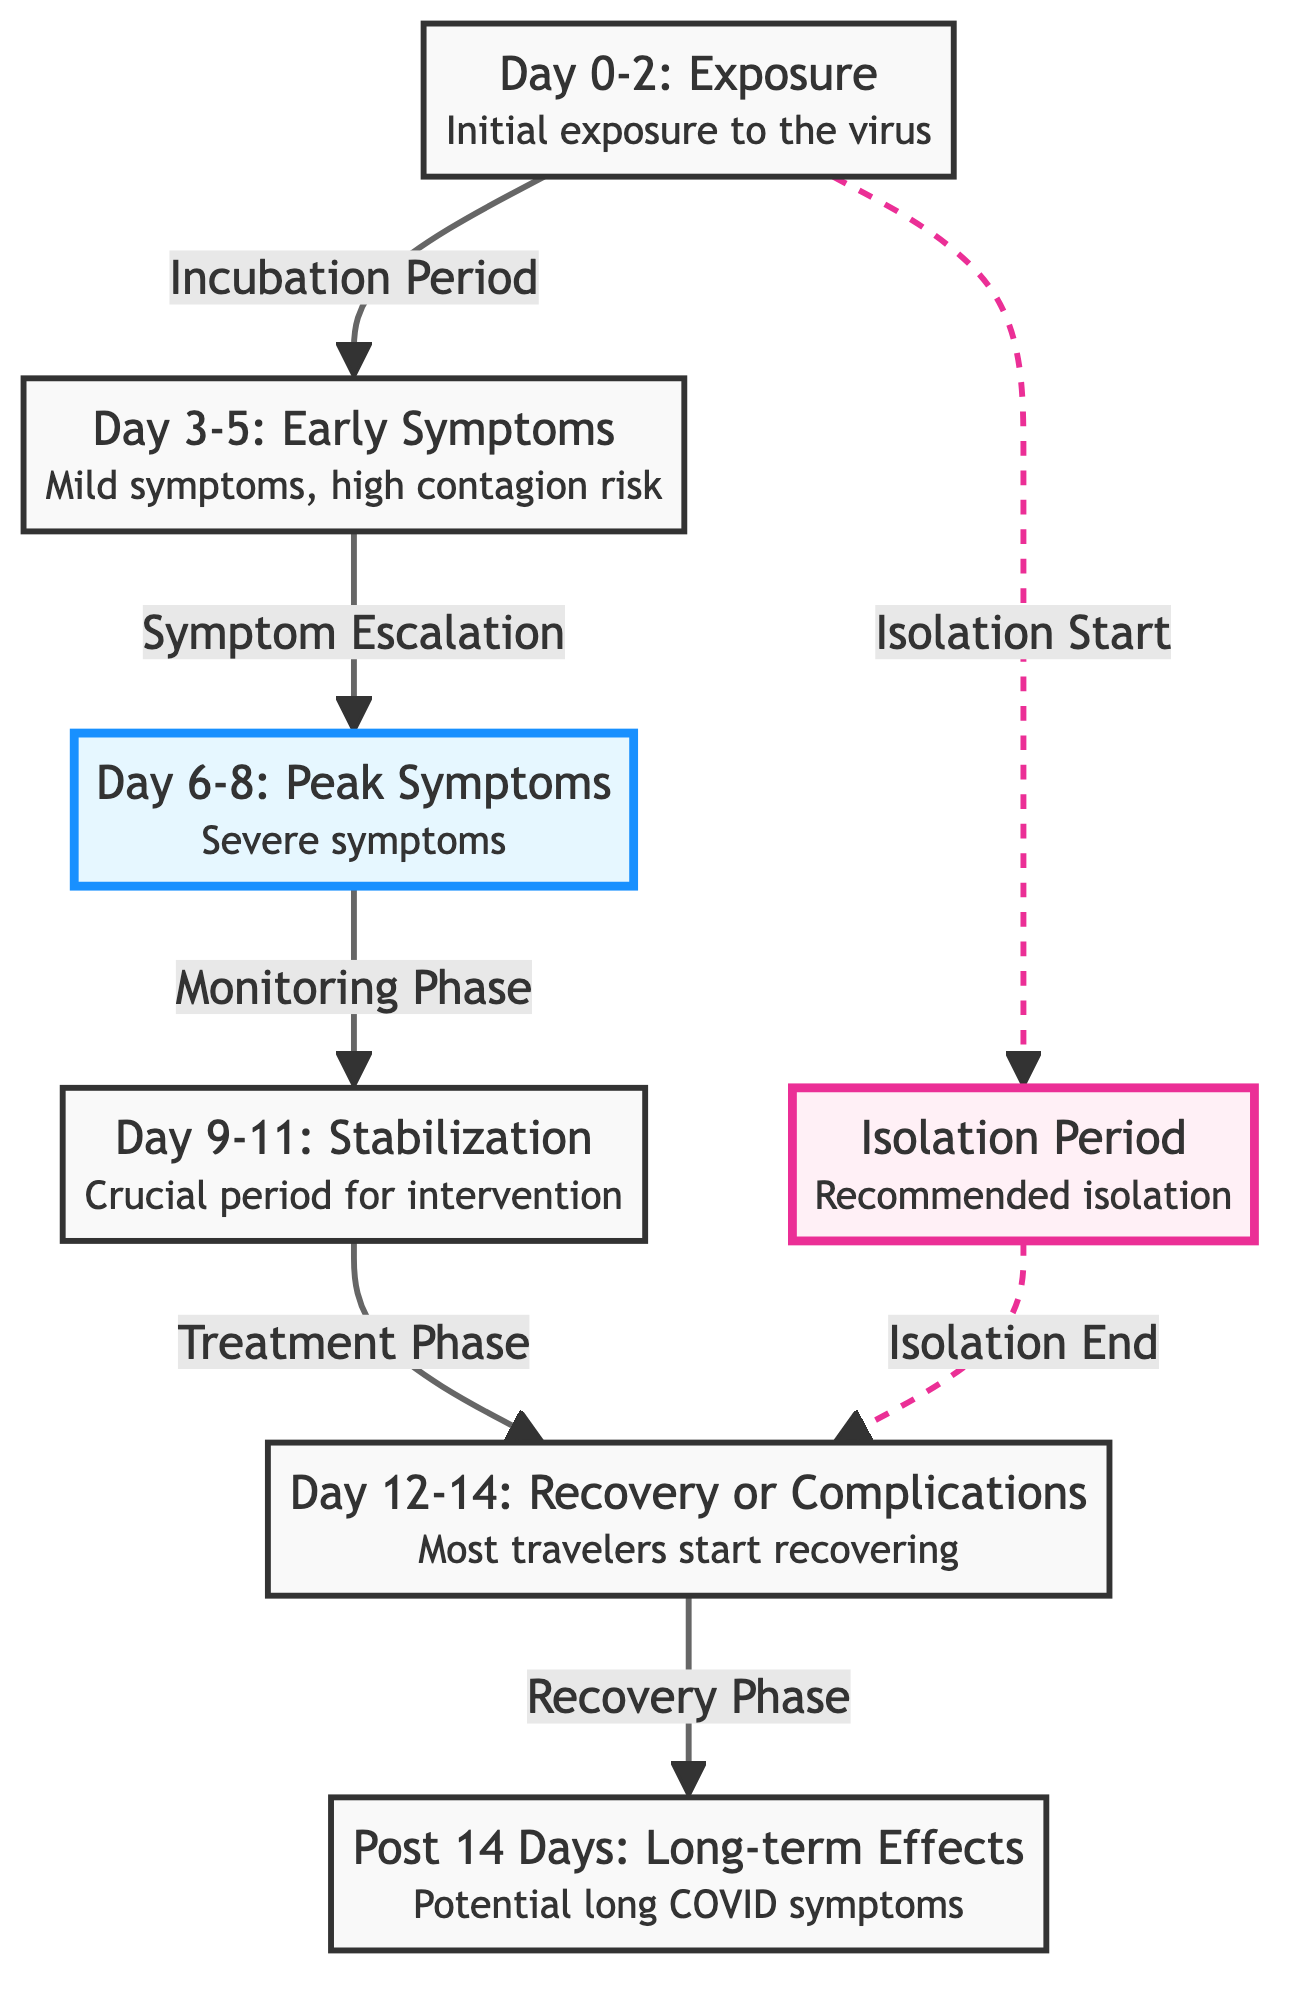What is the first stage of Covid-19 symptoms? The diagram indicates that the first stage is "Day 0-2: Exposure," which refers to the initial exposure to the virus.
Answer: Day 0-2: Exposure Which stage has severe symptoms? According to the diagram, "Day 6-8: Peak Symptoms" is when severe symptoms occur, making this the answer.
Answer: Day 6-8: Peak Symptoms What is the contagion risk during the early symptoms stage? The diagram specifies that during "Day 3-5: Early Symptoms," the contagion risk is high, which directly answers the question.
Answer: High contagion risk What happens during the stabilization phase? The diagram describes "Day 9-11: Stabilization" as a crucial period for intervention, indicating important actions or treatments take place during this time.
Answer: Crucial period for intervention How long does the recovery process typically last? The diagram suggests that recovery occurs during "Day 12-14: Recovery or Complications," indicating this is the timeframe for recovery in most travelers.
Answer: Day 12-14: Recovery or Complications What type of symptoms might persist after 14 days? According to the diagram, "Post 14 Days: Long-term Effects" includes potential long COVID symptoms, which suggests that these are the lingering issues travelers might face.
Answer: Potential long COVID symptoms What is the relationship between exposure and isolation? The diagram shows that isolation starts as soon as there is exposure to the virus, indicating that the exposure node has an arrow leading to the isolation period.
Answer: Isolation Start How many phases are there before recovery? The diagram outlines five distinct phases leading up to recovery, as shown from exposure to the stabilization phase before recovery.
Answer: Five phases What is indicated by the dashed line connected to the isolation? The dashed line suggests an indirect or conditional relationship; specifically, it indicates that there is a separation from isolation to recovery, representing a necessary step before returning to recovery after the isolation period.
Answer: Isolation End 